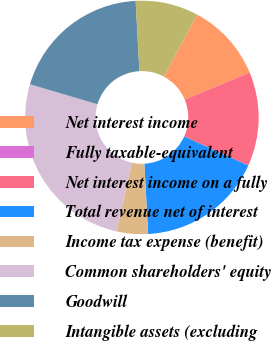Convert chart to OTSL. <chart><loc_0><loc_0><loc_500><loc_500><pie_chart><fcel>Net interest income<fcel>Fully taxable-equivalent<fcel>Net interest income on a fully<fcel>Total revenue net of interest<fcel>Income tax expense (benefit)<fcel>Common shareholders' equity<fcel>Goodwill<fcel>Intangible assets (excluding<nl><fcel>10.87%<fcel>0.0%<fcel>13.04%<fcel>17.39%<fcel>4.35%<fcel>26.08%<fcel>19.56%<fcel>8.7%<nl></chart> 